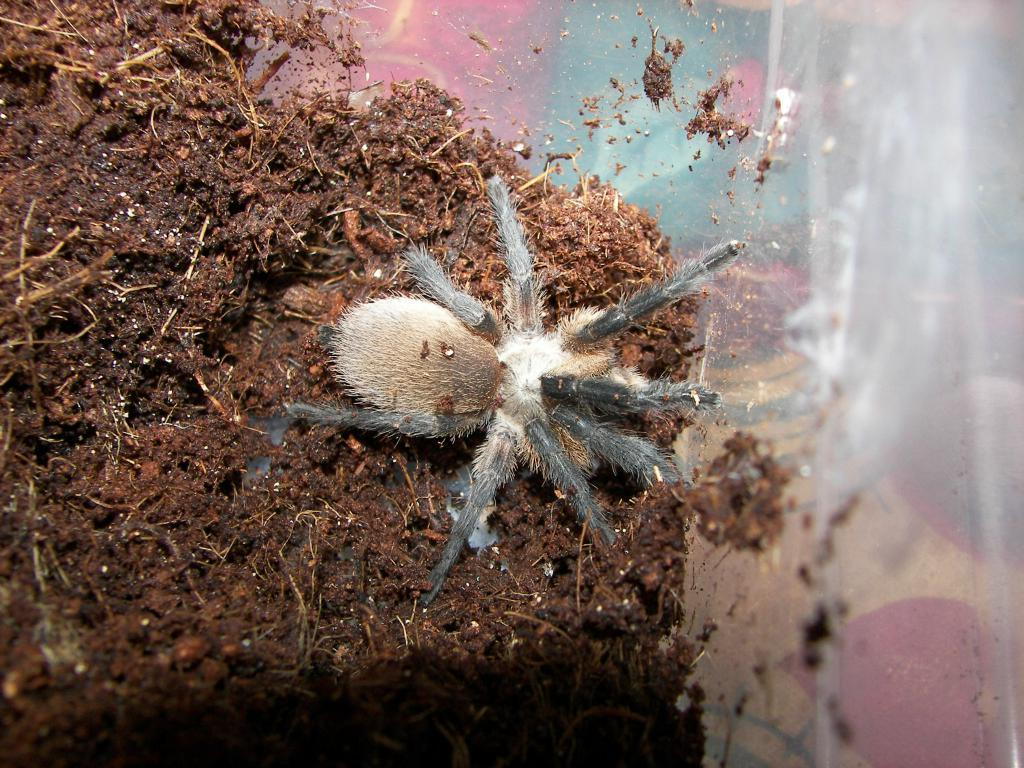What type of surface is visible in the image? There is soil visible in the image. What type of creature can be seen in the image? There is a spider in the image. What colors make up the spider's appearance? The spider's color is black and white. What type of dirt is visible in the image? There is no dirt visible in the image; it is soil that is present. What type of underwear is the spider wearing in the image? Spiders do not wear underwear, and therefore this detail cannot be observed in the image. 